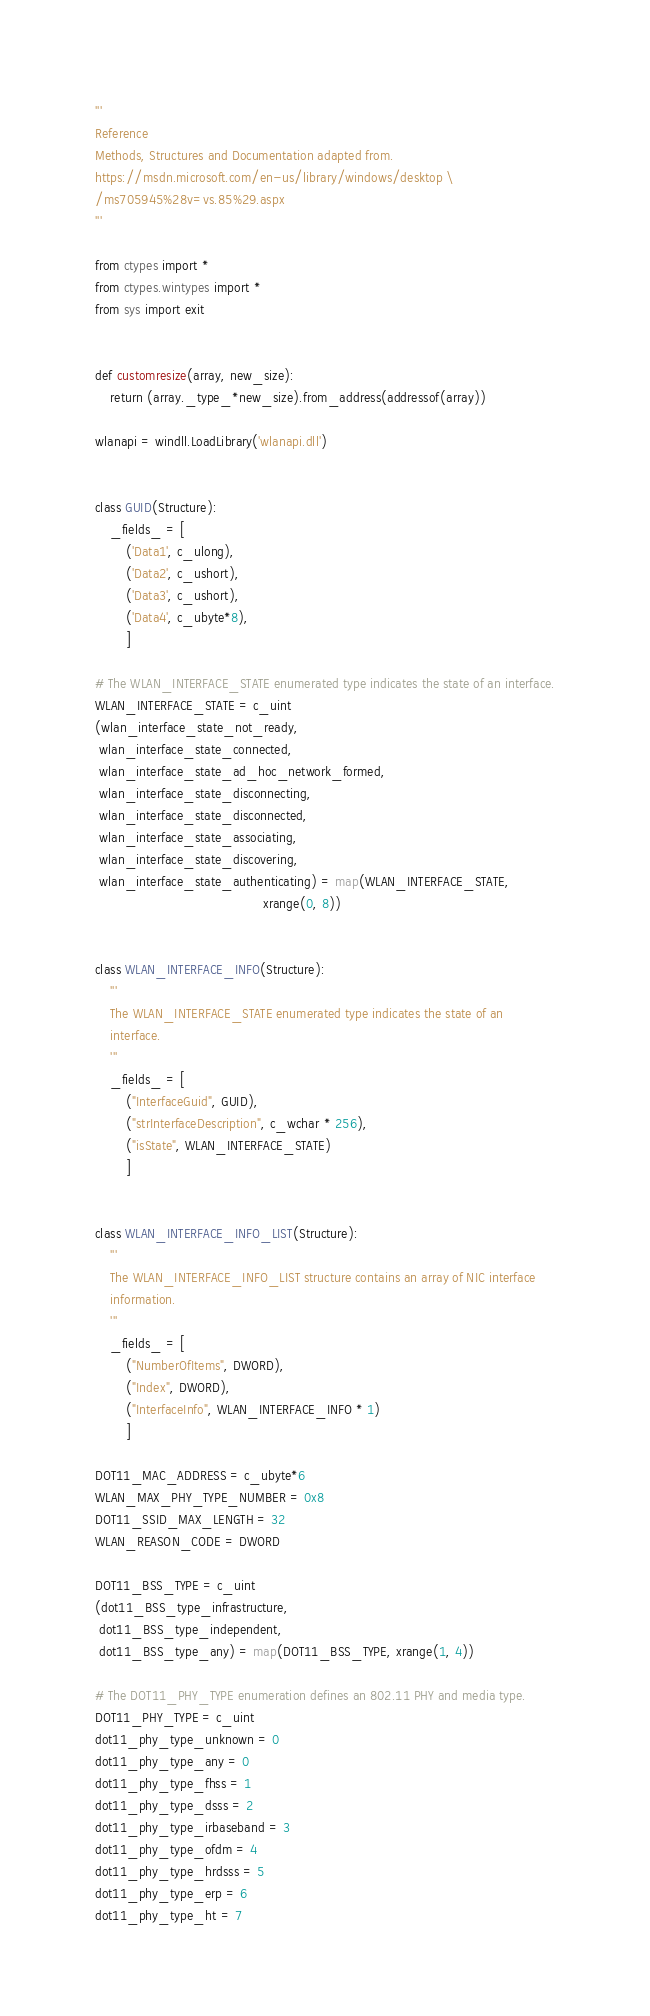<code> <loc_0><loc_0><loc_500><loc_500><_Python_>'''
Reference
Methods, Structures and Documentation adapted from.
https://msdn.microsoft.com/en-us/library/windows/desktop \
/ms705945%28v=vs.85%29.aspx
'''

from ctypes import *
from ctypes.wintypes import *
from sys import exit


def customresize(array, new_size):
    return (array._type_*new_size).from_address(addressof(array))

wlanapi = windll.LoadLibrary('wlanapi.dll')


class GUID(Structure):
    _fields_ = [
        ('Data1', c_ulong),
        ('Data2', c_ushort),
        ('Data3', c_ushort),
        ('Data4', c_ubyte*8),
        ]

# The WLAN_INTERFACE_STATE enumerated type indicates the state of an interface.
WLAN_INTERFACE_STATE = c_uint
(wlan_interface_state_not_ready,
 wlan_interface_state_connected,
 wlan_interface_state_ad_hoc_network_formed,
 wlan_interface_state_disconnecting,
 wlan_interface_state_disconnected,
 wlan_interface_state_associating,
 wlan_interface_state_discovering,
 wlan_interface_state_authenticating) = map(WLAN_INTERFACE_STATE,
                                            xrange(0, 8))


class WLAN_INTERFACE_INFO(Structure):
    '''
    The WLAN_INTERFACE_STATE enumerated type indicates the state of an
    interface.
    '''
    _fields_ = [
        ("InterfaceGuid", GUID),
        ("strInterfaceDescription", c_wchar * 256),
        ("isState", WLAN_INTERFACE_STATE)
        ]


class WLAN_INTERFACE_INFO_LIST(Structure):
    '''
    The WLAN_INTERFACE_INFO_LIST structure contains an array of NIC interface
    information.
    '''
    _fields_ = [
        ("NumberOfItems", DWORD),
        ("Index", DWORD),
        ("InterfaceInfo", WLAN_INTERFACE_INFO * 1)
        ]

DOT11_MAC_ADDRESS = c_ubyte*6
WLAN_MAX_PHY_TYPE_NUMBER = 0x8
DOT11_SSID_MAX_LENGTH = 32
WLAN_REASON_CODE = DWORD

DOT11_BSS_TYPE = c_uint
(dot11_BSS_type_infrastructure,
 dot11_BSS_type_independent,
 dot11_BSS_type_any) = map(DOT11_BSS_TYPE, xrange(1, 4))

# The DOT11_PHY_TYPE enumeration defines an 802.11 PHY and media type.
DOT11_PHY_TYPE = c_uint
dot11_phy_type_unknown = 0
dot11_phy_type_any = 0
dot11_phy_type_fhss = 1
dot11_phy_type_dsss = 2
dot11_phy_type_irbaseband = 3
dot11_phy_type_ofdm = 4
dot11_phy_type_hrdsss = 5
dot11_phy_type_erp = 6
dot11_phy_type_ht = 7</code> 